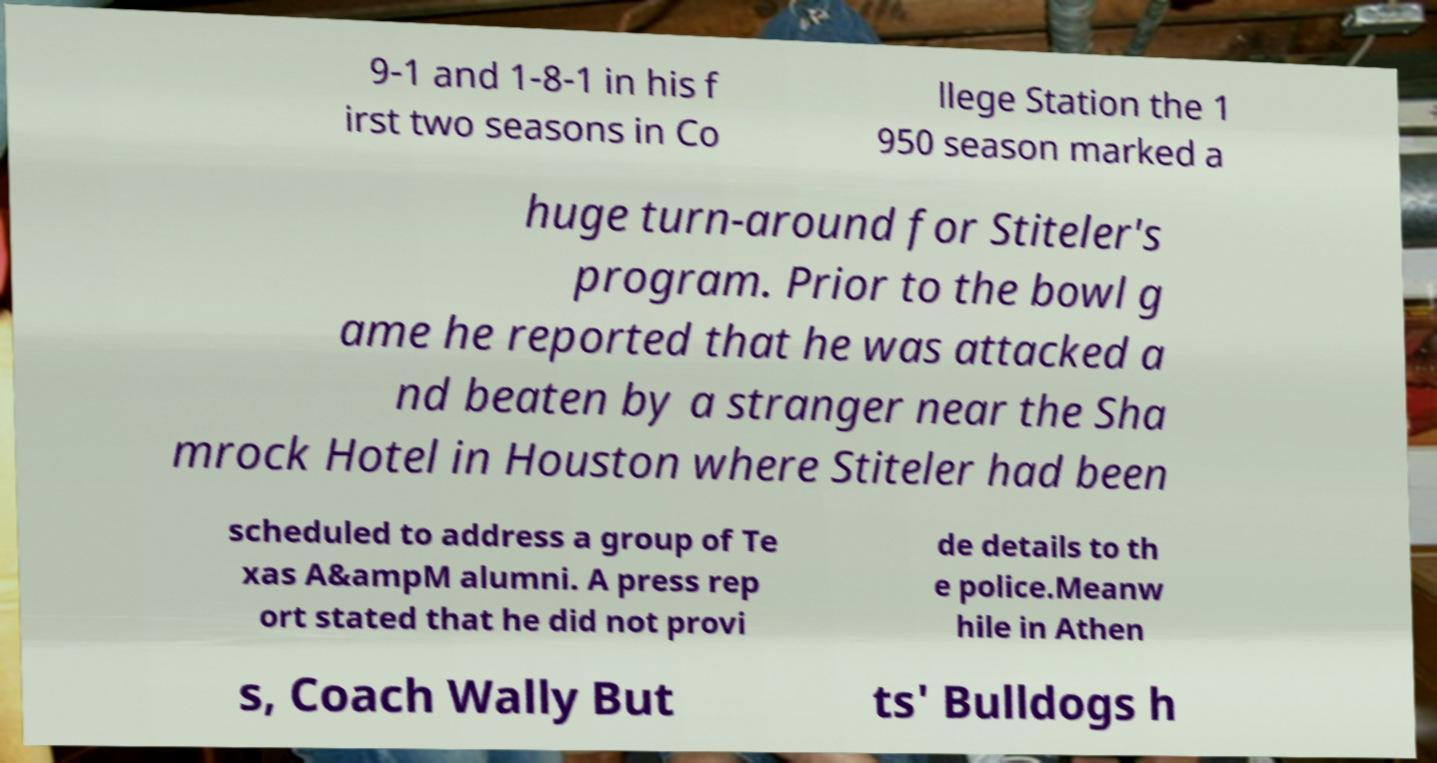Can you accurately transcribe the text from the provided image for me? 9-1 and 1-8-1 in his f irst two seasons in Co llege Station the 1 950 season marked a huge turn-around for Stiteler's program. Prior to the bowl g ame he reported that he was attacked a nd beaten by a stranger near the Sha mrock Hotel in Houston where Stiteler had been scheduled to address a group of Te xas A&ampM alumni. A press rep ort stated that he did not provi de details to th e police.Meanw hile in Athen s, Coach Wally But ts' Bulldogs h 